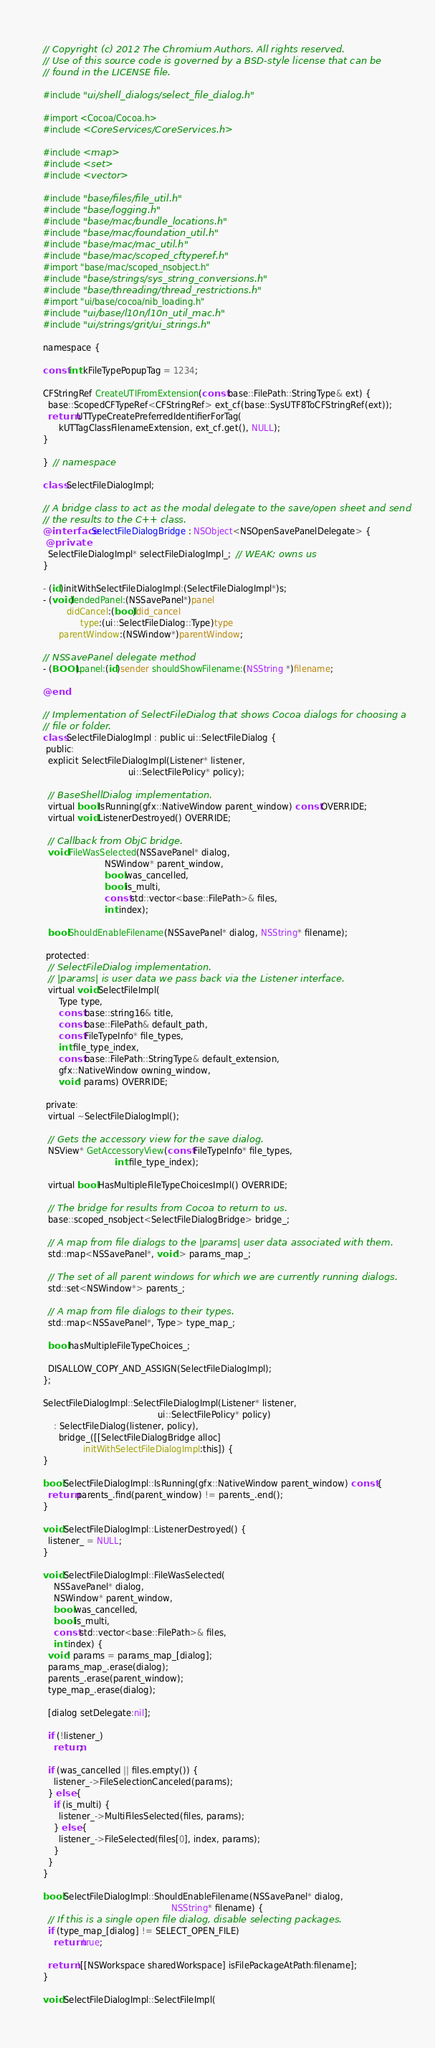Convert code to text. <code><loc_0><loc_0><loc_500><loc_500><_ObjectiveC_>// Copyright (c) 2012 The Chromium Authors. All rights reserved.
// Use of this source code is governed by a BSD-style license that can be
// found in the LICENSE file.

#include "ui/shell_dialogs/select_file_dialog.h"

#import <Cocoa/Cocoa.h>
#include <CoreServices/CoreServices.h>

#include <map>
#include <set>
#include <vector>

#include "base/files/file_util.h"
#include "base/logging.h"
#include "base/mac/bundle_locations.h"
#include "base/mac/foundation_util.h"
#include "base/mac/mac_util.h"
#include "base/mac/scoped_cftyperef.h"
#import "base/mac/scoped_nsobject.h"
#include "base/strings/sys_string_conversions.h"
#include "base/threading/thread_restrictions.h"
#import "ui/base/cocoa/nib_loading.h"
#include "ui/base/l10n/l10n_util_mac.h"
#include "ui/strings/grit/ui_strings.h"

namespace {

const int kFileTypePopupTag = 1234;

CFStringRef CreateUTIFromExtension(const base::FilePath::StringType& ext) {
  base::ScopedCFTypeRef<CFStringRef> ext_cf(base::SysUTF8ToCFStringRef(ext));
  return UTTypeCreatePreferredIdentifierForTag(
      kUTTagClassFilenameExtension, ext_cf.get(), NULL);
}

}  // namespace

class SelectFileDialogImpl;

// A bridge class to act as the modal delegate to the save/open sheet and send
// the results to the C++ class.
@interface SelectFileDialogBridge : NSObject<NSOpenSavePanelDelegate> {
 @private
  SelectFileDialogImpl* selectFileDialogImpl_;  // WEAK; owns us
}

- (id)initWithSelectFileDialogImpl:(SelectFileDialogImpl*)s;
- (void)endedPanel:(NSSavePanel*)panel
         didCancel:(bool)did_cancel
              type:(ui::SelectFileDialog::Type)type
      parentWindow:(NSWindow*)parentWindow;

// NSSavePanel delegate method
- (BOOL)panel:(id)sender shouldShowFilename:(NSString *)filename;

@end

// Implementation of SelectFileDialog that shows Cocoa dialogs for choosing a
// file or folder.
class SelectFileDialogImpl : public ui::SelectFileDialog {
 public:
  explicit SelectFileDialogImpl(Listener* listener,
                                ui::SelectFilePolicy* policy);

  // BaseShellDialog implementation.
  virtual bool IsRunning(gfx::NativeWindow parent_window) const OVERRIDE;
  virtual void ListenerDestroyed() OVERRIDE;

  // Callback from ObjC bridge.
  void FileWasSelected(NSSavePanel* dialog,
                       NSWindow* parent_window,
                       bool was_cancelled,
                       bool is_multi,
                       const std::vector<base::FilePath>& files,
                       int index);

  bool ShouldEnableFilename(NSSavePanel* dialog, NSString* filename);

 protected:
  // SelectFileDialog implementation.
  // |params| is user data we pass back via the Listener interface.
  virtual void SelectFileImpl(
      Type type,
      const base::string16& title,
      const base::FilePath& default_path,
      const FileTypeInfo* file_types,
      int file_type_index,
      const base::FilePath::StringType& default_extension,
      gfx::NativeWindow owning_window,
      void* params) OVERRIDE;

 private:
  virtual ~SelectFileDialogImpl();

  // Gets the accessory view for the save dialog.
  NSView* GetAccessoryView(const FileTypeInfo* file_types,
                           int file_type_index);

  virtual bool HasMultipleFileTypeChoicesImpl() OVERRIDE;

  // The bridge for results from Cocoa to return to us.
  base::scoped_nsobject<SelectFileDialogBridge> bridge_;

  // A map from file dialogs to the |params| user data associated with them.
  std::map<NSSavePanel*, void*> params_map_;

  // The set of all parent windows for which we are currently running dialogs.
  std::set<NSWindow*> parents_;

  // A map from file dialogs to their types.
  std::map<NSSavePanel*, Type> type_map_;

  bool hasMultipleFileTypeChoices_;

  DISALLOW_COPY_AND_ASSIGN(SelectFileDialogImpl);
};

SelectFileDialogImpl::SelectFileDialogImpl(Listener* listener,
                                           ui::SelectFilePolicy* policy)
    : SelectFileDialog(listener, policy),
      bridge_([[SelectFileDialogBridge alloc]
               initWithSelectFileDialogImpl:this]) {
}

bool SelectFileDialogImpl::IsRunning(gfx::NativeWindow parent_window) const {
  return parents_.find(parent_window) != parents_.end();
}

void SelectFileDialogImpl::ListenerDestroyed() {
  listener_ = NULL;
}

void SelectFileDialogImpl::FileWasSelected(
    NSSavePanel* dialog,
    NSWindow* parent_window,
    bool was_cancelled,
    bool is_multi,
    const std::vector<base::FilePath>& files,
    int index) {
  void* params = params_map_[dialog];
  params_map_.erase(dialog);
  parents_.erase(parent_window);
  type_map_.erase(dialog);

  [dialog setDelegate:nil];

  if (!listener_)
    return;

  if (was_cancelled || files.empty()) {
    listener_->FileSelectionCanceled(params);
  } else {
    if (is_multi) {
      listener_->MultiFilesSelected(files, params);
    } else {
      listener_->FileSelected(files[0], index, params);
    }
  }
}

bool SelectFileDialogImpl::ShouldEnableFilename(NSSavePanel* dialog,
                                                NSString* filename) {
  // If this is a single open file dialog, disable selecting packages.
  if (type_map_[dialog] != SELECT_OPEN_FILE)
    return true;

  return ![[NSWorkspace sharedWorkspace] isFilePackageAtPath:filename];
}

void SelectFileDialogImpl::SelectFileImpl(</code> 